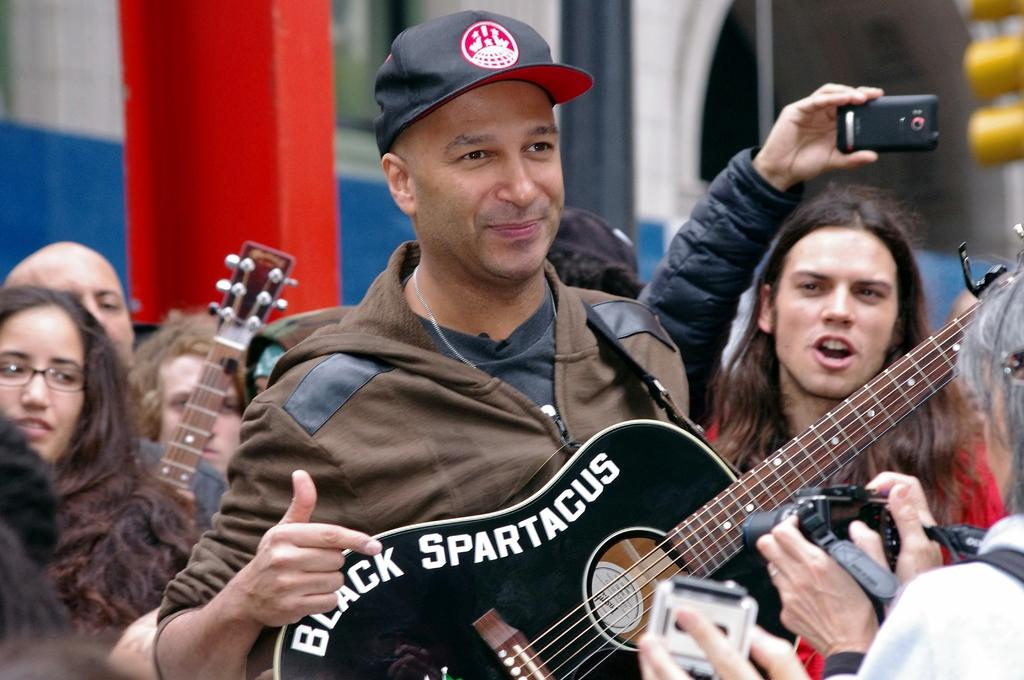How many people are in the image? There is a group of people in the image. What is one man holding in the image? One man is holding a guitar. What is another man holding in the image? Another man is holding a mobile phone. What type of test is being conducted in the image? There is no test being conducted in the image; it features a group of people with a man holding a guitar and another holding a mobile phone. 